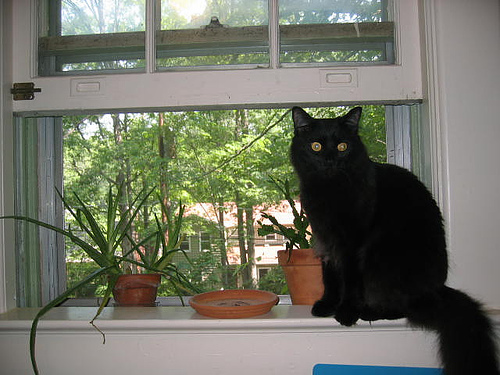<image>
Is there a cat on the window? Yes. Looking at the image, I can see the cat is positioned on top of the window, with the window providing support. Is there a cat on the pot? No. The cat is not positioned on the pot. They may be near each other, but the cat is not supported by or resting on top of the pot. Is the cat behind the potted plant? No. The cat is not behind the potted plant. From this viewpoint, the cat appears to be positioned elsewhere in the scene. 